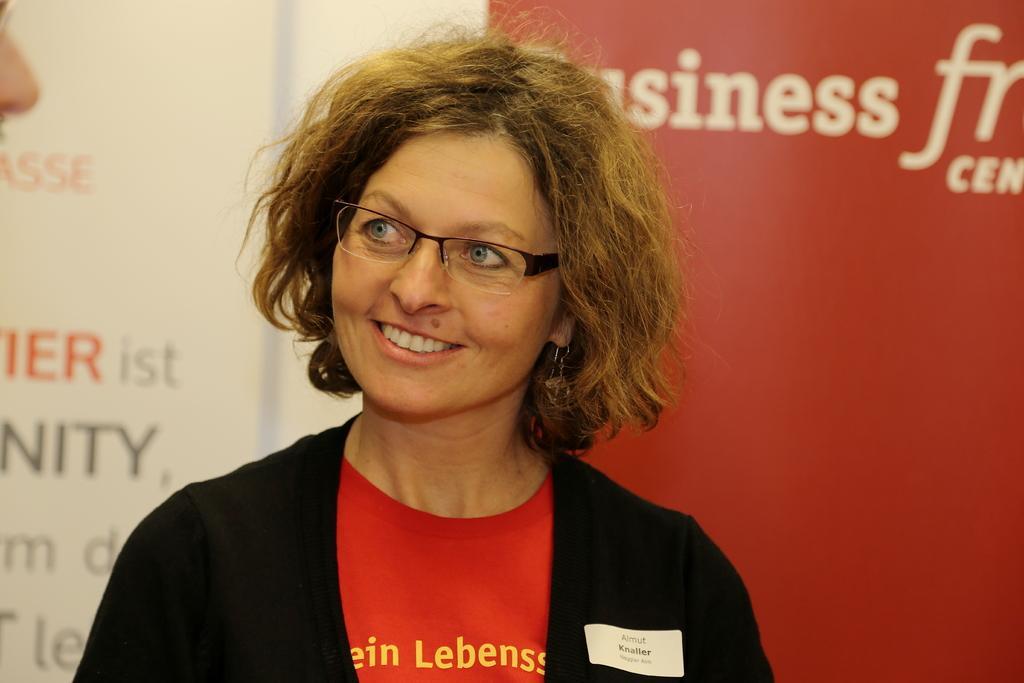In one or two sentences, can you explain what this image depicts? This is the woman standing and smiling. She wore a jacket, T-shirt and spectacles. In the background, that looks like a banner. 